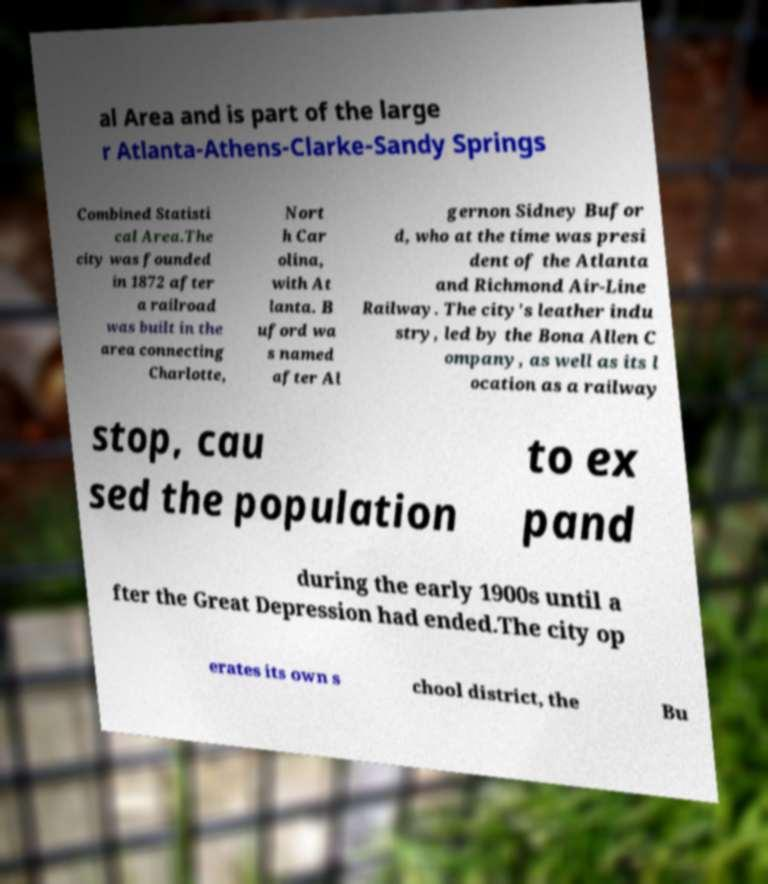What messages or text are displayed in this image? I need them in a readable, typed format. al Area and is part of the large r Atlanta-Athens-Clarke-Sandy Springs Combined Statisti cal Area.The city was founded in 1872 after a railroad was built in the area connecting Charlotte, Nort h Car olina, with At lanta. B uford wa s named after Al gernon Sidney Bufor d, who at the time was presi dent of the Atlanta and Richmond Air-Line Railway. The city's leather indu stry, led by the Bona Allen C ompany, as well as its l ocation as a railway stop, cau sed the population to ex pand during the early 1900s until a fter the Great Depression had ended.The city op erates its own s chool district, the Bu 